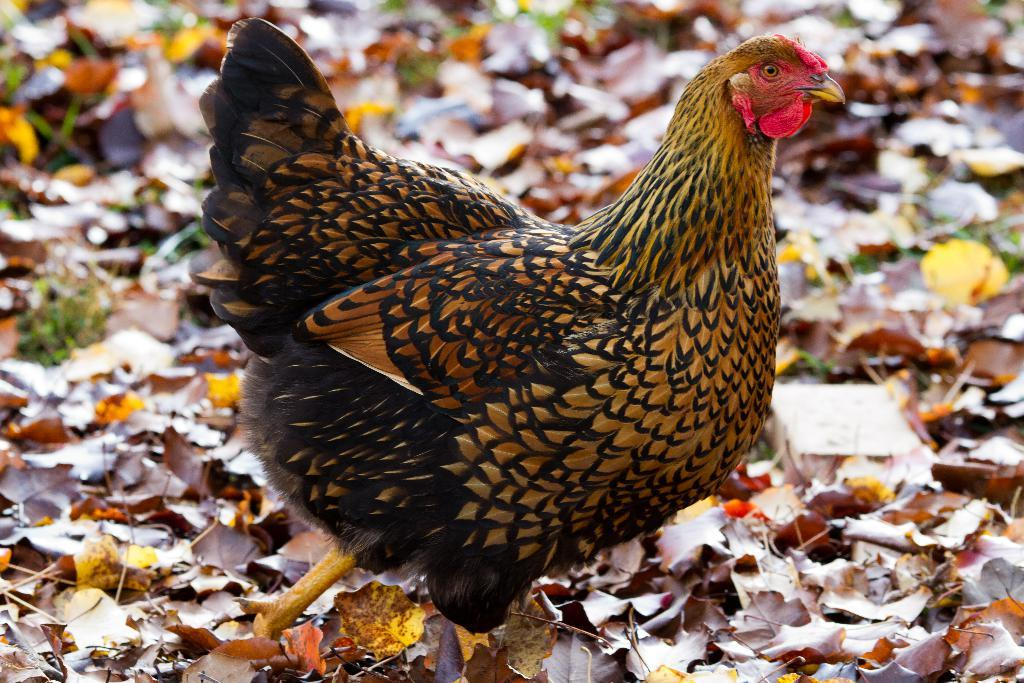What animal can be seen on the ground in the image? There is a hen on the ground in the image. What type of vegetation is visible in the background of the image? Dried leaves and grass are present in the background of the image. What type of iron is being used to reward the hen in the image? There is no iron or reward present in the image; it features a hen on the ground and dried leaves and grass in the background. 